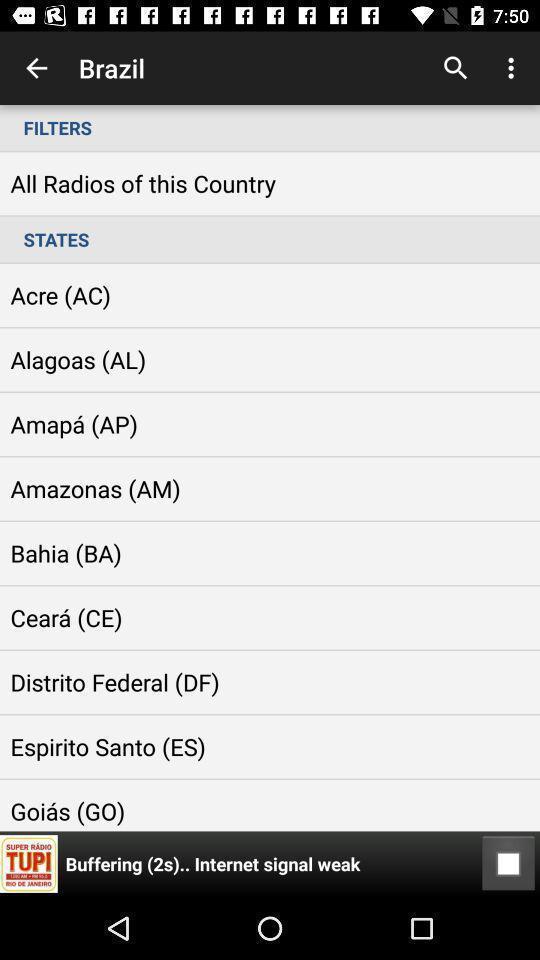Explain the elements present in this screenshot. Screen shows filters of radio of a country. 